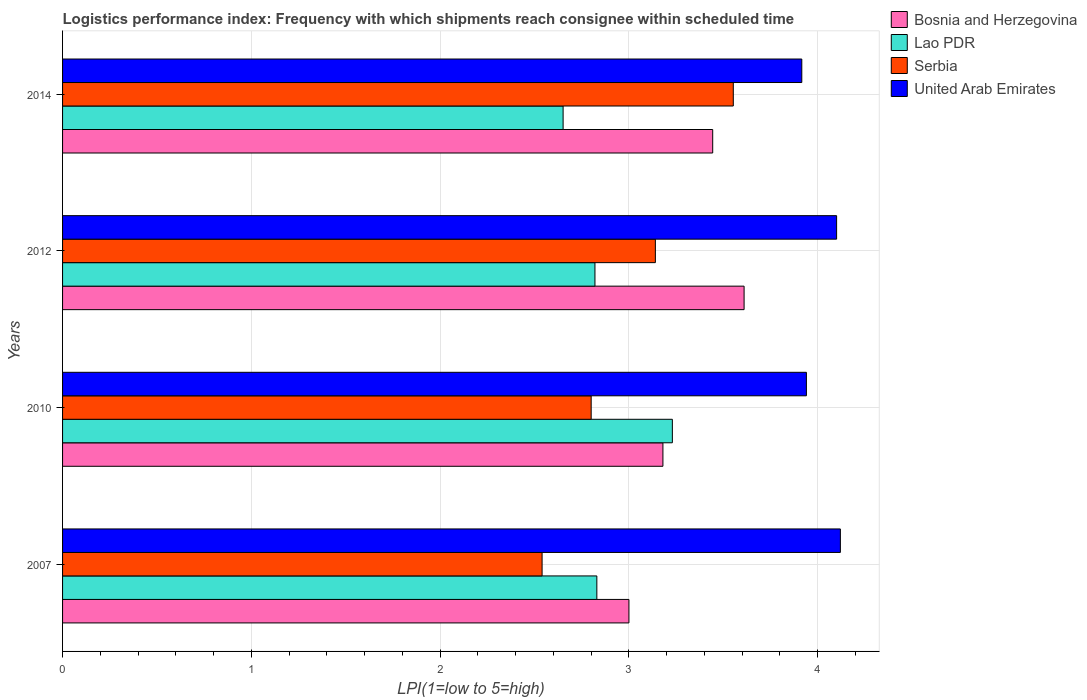How many different coloured bars are there?
Ensure brevity in your answer.  4. How many groups of bars are there?
Give a very brief answer. 4. Are the number of bars per tick equal to the number of legend labels?
Offer a terse response. Yes. How many bars are there on the 2nd tick from the top?
Give a very brief answer. 4. What is the label of the 2nd group of bars from the top?
Your answer should be very brief. 2012. What is the logistics performance index in Bosnia and Herzegovina in 2014?
Ensure brevity in your answer.  3.44. Across all years, what is the maximum logistics performance index in United Arab Emirates?
Keep it short and to the point. 4.12. Across all years, what is the minimum logistics performance index in Serbia?
Provide a short and direct response. 2.54. In which year was the logistics performance index in Bosnia and Herzegovina maximum?
Your answer should be very brief. 2012. In which year was the logistics performance index in Serbia minimum?
Offer a terse response. 2007. What is the total logistics performance index in United Arab Emirates in the graph?
Make the answer very short. 16.08. What is the difference between the logistics performance index in Bosnia and Herzegovina in 2012 and that in 2014?
Ensure brevity in your answer.  0.17. What is the difference between the logistics performance index in Serbia in 2007 and the logistics performance index in Bosnia and Herzegovina in 2012?
Give a very brief answer. -1.07. What is the average logistics performance index in Bosnia and Herzegovina per year?
Provide a short and direct response. 3.31. In the year 2014, what is the difference between the logistics performance index in Bosnia and Herzegovina and logistics performance index in Serbia?
Keep it short and to the point. -0.11. In how many years, is the logistics performance index in Serbia greater than 2.6 ?
Offer a very short reply. 3. What is the ratio of the logistics performance index in Bosnia and Herzegovina in 2010 to that in 2014?
Give a very brief answer. 0.92. Is the difference between the logistics performance index in Bosnia and Herzegovina in 2007 and 2014 greater than the difference between the logistics performance index in Serbia in 2007 and 2014?
Your answer should be very brief. Yes. What is the difference between the highest and the second highest logistics performance index in United Arab Emirates?
Your answer should be compact. 0.02. What is the difference between the highest and the lowest logistics performance index in Bosnia and Herzegovina?
Offer a very short reply. 0.61. What does the 1st bar from the top in 2007 represents?
Your answer should be very brief. United Arab Emirates. What does the 1st bar from the bottom in 2007 represents?
Offer a very short reply. Bosnia and Herzegovina. Is it the case that in every year, the sum of the logistics performance index in Bosnia and Herzegovina and logistics performance index in Serbia is greater than the logistics performance index in United Arab Emirates?
Your answer should be very brief. Yes. Are all the bars in the graph horizontal?
Your answer should be very brief. Yes. How many years are there in the graph?
Your answer should be compact. 4. What is the difference between two consecutive major ticks on the X-axis?
Keep it short and to the point. 1. Are the values on the major ticks of X-axis written in scientific E-notation?
Give a very brief answer. No. Does the graph contain grids?
Your response must be concise. Yes. Where does the legend appear in the graph?
Your response must be concise. Top right. How many legend labels are there?
Make the answer very short. 4. How are the legend labels stacked?
Keep it short and to the point. Vertical. What is the title of the graph?
Your answer should be compact. Logistics performance index: Frequency with which shipments reach consignee within scheduled time. Does "Middle East & North Africa (developing only)" appear as one of the legend labels in the graph?
Your answer should be compact. No. What is the label or title of the X-axis?
Give a very brief answer. LPI(1=low to 5=high). What is the LPI(1=low to 5=high) in Bosnia and Herzegovina in 2007?
Offer a very short reply. 3. What is the LPI(1=low to 5=high) in Lao PDR in 2007?
Provide a short and direct response. 2.83. What is the LPI(1=low to 5=high) in Serbia in 2007?
Make the answer very short. 2.54. What is the LPI(1=low to 5=high) in United Arab Emirates in 2007?
Offer a very short reply. 4.12. What is the LPI(1=low to 5=high) in Bosnia and Herzegovina in 2010?
Ensure brevity in your answer.  3.18. What is the LPI(1=low to 5=high) of Lao PDR in 2010?
Your answer should be very brief. 3.23. What is the LPI(1=low to 5=high) in Serbia in 2010?
Provide a succinct answer. 2.8. What is the LPI(1=low to 5=high) of United Arab Emirates in 2010?
Your answer should be compact. 3.94. What is the LPI(1=low to 5=high) in Bosnia and Herzegovina in 2012?
Provide a short and direct response. 3.61. What is the LPI(1=low to 5=high) in Lao PDR in 2012?
Offer a terse response. 2.82. What is the LPI(1=low to 5=high) in Serbia in 2012?
Provide a short and direct response. 3.14. What is the LPI(1=low to 5=high) of Bosnia and Herzegovina in 2014?
Make the answer very short. 3.44. What is the LPI(1=low to 5=high) of Lao PDR in 2014?
Keep it short and to the point. 2.65. What is the LPI(1=low to 5=high) of Serbia in 2014?
Offer a very short reply. 3.55. What is the LPI(1=low to 5=high) in United Arab Emirates in 2014?
Give a very brief answer. 3.92. Across all years, what is the maximum LPI(1=low to 5=high) in Bosnia and Herzegovina?
Provide a succinct answer. 3.61. Across all years, what is the maximum LPI(1=low to 5=high) of Lao PDR?
Your answer should be compact. 3.23. Across all years, what is the maximum LPI(1=low to 5=high) in Serbia?
Ensure brevity in your answer.  3.55. Across all years, what is the maximum LPI(1=low to 5=high) of United Arab Emirates?
Provide a short and direct response. 4.12. Across all years, what is the minimum LPI(1=low to 5=high) in Lao PDR?
Keep it short and to the point. 2.65. Across all years, what is the minimum LPI(1=low to 5=high) in Serbia?
Your answer should be very brief. 2.54. Across all years, what is the minimum LPI(1=low to 5=high) in United Arab Emirates?
Offer a terse response. 3.92. What is the total LPI(1=low to 5=high) of Bosnia and Herzegovina in the graph?
Offer a very short reply. 13.23. What is the total LPI(1=low to 5=high) of Lao PDR in the graph?
Keep it short and to the point. 11.53. What is the total LPI(1=low to 5=high) of Serbia in the graph?
Provide a short and direct response. 12.03. What is the total LPI(1=low to 5=high) of United Arab Emirates in the graph?
Give a very brief answer. 16.08. What is the difference between the LPI(1=low to 5=high) of Bosnia and Herzegovina in 2007 and that in 2010?
Your answer should be very brief. -0.18. What is the difference between the LPI(1=low to 5=high) of Lao PDR in 2007 and that in 2010?
Offer a very short reply. -0.4. What is the difference between the LPI(1=low to 5=high) in Serbia in 2007 and that in 2010?
Give a very brief answer. -0.26. What is the difference between the LPI(1=low to 5=high) in United Arab Emirates in 2007 and that in 2010?
Provide a short and direct response. 0.18. What is the difference between the LPI(1=low to 5=high) of Bosnia and Herzegovina in 2007 and that in 2012?
Your answer should be very brief. -0.61. What is the difference between the LPI(1=low to 5=high) of Serbia in 2007 and that in 2012?
Offer a terse response. -0.6. What is the difference between the LPI(1=low to 5=high) of United Arab Emirates in 2007 and that in 2012?
Ensure brevity in your answer.  0.02. What is the difference between the LPI(1=low to 5=high) of Bosnia and Herzegovina in 2007 and that in 2014?
Offer a terse response. -0.44. What is the difference between the LPI(1=low to 5=high) of Lao PDR in 2007 and that in 2014?
Offer a very short reply. 0.18. What is the difference between the LPI(1=low to 5=high) in Serbia in 2007 and that in 2014?
Offer a terse response. -1.01. What is the difference between the LPI(1=low to 5=high) of United Arab Emirates in 2007 and that in 2014?
Provide a succinct answer. 0.2. What is the difference between the LPI(1=low to 5=high) of Bosnia and Herzegovina in 2010 and that in 2012?
Your answer should be very brief. -0.43. What is the difference between the LPI(1=low to 5=high) of Lao PDR in 2010 and that in 2012?
Offer a very short reply. 0.41. What is the difference between the LPI(1=low to 5=high) of Serbia in 2010 and that in 2012?
Make the answer very short. -0.34. What is the difference between the LPI(1=low to 5=high) of United Arab Emirates in 2010 and that in 2012?
Provide a short and direct response. -0.16. What is the difference between the LPI(1=low to 5=high) in Bosnia and Herzegovina in 2010 and that in 2014?
Offer a very short reply. -0.26. What is the difference between the LPI(1=low to 5=high) of Lao PDR in 2010 and that in 2014?
Keep it short and to the point. 0.58. What is the difference between the LPI(1=low to 5=high) in Serbia in 2010 and that in 2014?
Offer a terse response. -0.75. What is the difference between the LPI(1=low to 5=high) of United Arab Emirates in 2010 and that in 2014?
Provide a short and direct response. 0.02. What is the difference between the LPI(1=low to 5=high) of Bosnia and Herzegovina in 2012 and that in 2014?
Offer a very short reply. 0.17. What is the difference between the LPI(1=low to 5=high) in Lao PDR in 2012 and that in 2014?
Provide a succinct answer. 0.17. What is the difference between the LPI(1=low to 5=high) in Serbia in 2012 and that in 2014?
Give a very brief answer. -0.41. What is the difference between the LPI(1=low to 5=high) in United Arab Emirates in 2012 and that in 2014?
Keep it short and to the point. 0.18. What is the difference between the LPI(1=low to 5=high) in Bosnia and Herzegovina in 2007 and the LPI(1=low to 5=high) in Lao PDR in 2010?
Your response must be concise. -0.23. What is the difference between the LPI(1=low to 5=high) in Bosnia and Herzegovina in 2007 and the LPI(1=low to 5=high) in Serbia in 2010?
Provide a short and direct response. 0.2. What is the difference between the LPI(1=low to 5=high) of Bosnia and Herzegovina in 2007 and the LPI(1=low to 5=high) of United Arab Emirates in 2010?
Ensure brevity in your answer.  -0.94. What is the difference between the LPI(1=low to 5=high) in Lao PDR in 2007 and the LPI(1=low to 5=high) in United Arab Emirates in 2010?
Ensure brevity in your answer.  -1.11. What is the difference between the LPI(1=low to 5=high) of Bosnia and Herzegovina in 2007 and the LPI(1=low to 5=high) of Lao PDR in 2012?
Provide a succinct answer. 0.18. What is the difference between the LPI(1=low to 5=high) in Bosnia and Herzegovina in 2007 and the LPI(1=low to 5=high) in Serbia in 2012?
Provide a succinct answer. -0.14. What is the difference between the LPI(1=low to 5=high) of Bosnia and Herzegovina in 2007 and the LPI(1=low to 5=high) of United Arab Emirates in 2012?
Keep it short and to the point. -1.1. What is the difference between the LPI(1=low to 5=high) of Lao PDR in 2007 and the LPI(1=low to 5=high) of Serbia in 2012?
Make the answer very short. -0.31. What is the difference between the LPI(1=low to 5=high) of Lao PDR in 2007 and the LPI(1=low to 5=high) of United Arab Emirates in 2012?
Provide a succinct answer. -1.27. What is the difference between the LPI(1=low to 5=high) of Serbia in 2007 and the LPI(1=low to 5=high) of United Arab Emirates in 2012?
Ensure brevity in your answer.  -1.56. What is the difference between the LPI(1=low to 5=high) in Bosnia and Herzegovina in 2007 and the LPI(1=low to 5=high) in Lao PDR in 2014?
Ensure brevity in your answer.  0.35. What is the difference between the LPI(1=low to 5=high) in Bosnia and Herzegovina in 2007 and the LPI(1=low to 5=high) in Serbia in 2014?
Your response must be concise. -0.55. What is the difference between the LPI(1=low to 5=high) in Bosnia and Herzegovina in 2007 and the LPI(1=low to 5=high) in United Arab Emirates in 2014?
Offer a terse response. -0.92. What is the difference between the LPI(1=low to 5=high) in Lao PDR in 2007 and the LPI(1=low to 5=high) in Serbia in 2014?
Your response must be concise. -0.72. What is the difference between the LPI(1=low to 5=high) of Lao PDR in 2007 and the LPI(1=low to 5=high) of United Arab Emirates in 2014?
Offer a very short reply. -1.09. What is the difference between the LPI(1=low to 5=high) in Serbia in 2007 and the LPI(1=low to 5=high) in United Arab Emirates in 2014?
Keep it short and to the point. -1.38. What is the difference between the LPI(1=low to 5=high) in Bosnia and Herzegovina in 2010 and the LPI(1=low to 5=high) in Lao PDR in 2012?
Give a very brief answer. 0.36. What is the difference between the LPI(1=low to 5=high) of Bosnia and Herzegovina in 2010 and the LPI(1=low to 5=high) of United Arab Emirates in 2012?
Provide a succinct answer. -0.92. What is the difference between the LPI(1=low to 5=high) of Lao PDR in 2010 and the LPI(1=low to 5=high) of Serbia in 2012?
Provide a short and direct response. 0.09. What is the difference between the LPI(1=low to 5=high) in Lao PDR in 2010 and the LPI(1=low to 5=high) in United Arab Emirates in 2012?
Ensure brevity in your answer.  -0.87. What is the difference between the LPI(1=low to 5=high) in Bosnia and Herzegovina in 2010 and the LPI(1=low to 5=high) in Lao PDR in 2014?
Your answer should be compact. 0.53. What is the difference between the LPI(1=low to 5=high) in Bosnia and Herzegovina in 2010 and the LPI(1=low to 5=high) in Serbia in 2014?
Offer a terse response. -0.37. What is the difference between the LPI(1=low to 5=high) of Bosnia and Herzegovina in 2010 and the LPI(1=low to 5=high) of United Arab Emirates in 2014?
Offer a terse response. -0.74. What is the difference between the LPI(1=low to 5=high) in Lao PDR in 2010 and the LPI(1=low to 5=high) in Serbia in 2014?
Provide a succinct answer. -0.32. What is the difference between the LPI(1=low to 5=high) of Lao PDR in 2010 and the LPI(1=low to 5=high) of United Arab Emirates in 2014?
Offer a terse response. -0.69. What is the difference between the LPI(1=low to 5=high) in Serbia in 2010 and the LPI(1=low to 5=high) in United Arab Emirates in 2014?
Offer a terse response. -1.12. What is the difference between the LPI(1=low to 5=high) of Bosnia and Herzegovina in 2012 and the LPI(1=low to 5=high) of Lao PDR in 2014?
Provide a succinct answer. 0.96. What is the difference between the LPI(1=low to 5=high) of Bosnia and Herzegovina in 2012 and the LPI(1=low to 5=high) of Serbia in 2014?
Offer a very short reply. 0.06. What is the difference between the LPI(1=low to 5=high) of Bosnia and Herzegovina in 2012 and the LPI(1=low to 5=high) of United Arab Emirates in 2014?
Make the answer very short. -0.31. What is the difference between the LPI(1=low to 5=high) in Lao PDR in 2012 and the LPI(1=low to 5=high) in Serbia in 2014?
Ensure brevity in your answer.  -0.73. What is the difference between the LPI(1=low to 5=high) of Lao PDR in 2012 and the LPI(1=low to 5=high) of United Arab Emirates in 2014?
Give a very brief answer. -1.1. What is the difference between the LPI(1=low to 5=high) of Serbia in 2012 and the LPI(1=low to 5=high) of United Arab Emirates in 2014?
Ensure brevity in your answer.  -0.78. What is the average LPI(1=low to 5=high) of Bosnia and Herzegovina per year?
Give a very brief answer. 3.31. What is the average LPI(1=low to 5=high) of Lao PDR per year?
Offer a very short reply. 2.88. What is the average LPI(1=low to 5=high) in Serbia per year?
Offer a very short reply. 3.01. What is the average LPI(1=low to 5=high) of United Arab Emirates per year?
Your answer should be compact. 4.02. In the year 2007, what is the difference between the LPI(1=low to 5=high) in Bosnia and Herzegovina and LPI(1=low to 5=high) in Lao PDR?
Ensure brevity in your answer.  0.17. In the year 2007, what is the difference between the LPI(1=low to 5=high) in Bosnia and Herzegovina and LPI(1=low to 5=high) in Serbia?
Give a very brief answer. 0.46. In the year 2007, what is the difference between the LPI(1=low to 5=high) of Bosnia and Herzegovina and LPI(1=low to 5=high) of United Arab Emirates?
Provide a succinct answer. -1.12. In the year 2007, what is the difference between the LPI(1=low to 5=high) of Lao PDR and LPI(1=low to 5=high) of Serbia?
Offer a terse response. 0.29. In the year 2007, what is the difference between the LPI(1=low to 5=high) of Lao PDR and LPI(1=low to 5=high) of United Arab Emirates?
Offer a very short reply. -1.29. In the year 2007, what is the difference between the LPI(1=low to 5=high) of Serbia and LPI(1=low to 5=high) of United Arab Emirates?
Offer a very short reply. -1.58. In the year 2010, what is the difference between the LPI(1=low to 5=high) in Bosnia and Herzegovina and LPI(1=low to 5=high) in Serbia?
Offer a terse response. 0.38. In the year 2010, what is the difference between the LPI(1=low to 5=high) in Bosnia and Herzegovina and LPI(1=low to 5=high) in United Arab Emirates?
Your response must be concise. -0.76. In the year 2010, what is the difference between the LPI(1=low to 5=high) of Lao PDR and LPI(1=low to 5=high) of Serbia?
Provide a succinct answer. 0.43. In the year 2010, what is the difference between the LPI(1=low to 5=high) of Lao PDR and LPI(1=low to 5=high) of United Arab Emirates?
Ensure brevity in your answer.  -0.71. In the year 2010, what is the difference between the LPI(1=low to 5=high) in Serbia and LPI(1=low to 5=high) in United Arab Emirates?
Make the answer very short. -1.14. In the year 2012, what is the difference between the LPI(1=low to 5=high) of Bosnia and Herzegovina and LPI(1=low to 5=high) of Lao PDR?
Offer a very short reply. 0.79. In the year 2012, what is the difference between the LPI(1=low to 5=high) in Bosnia and Herzegovina and LPI(1=low to 5=high) in Serbia?
Your response must be concise. 0.47. In the year 2012, what is the difference between the LPI(1=low to 5=high) of Bosnia and Herzegovina and LPI(1=low to 5=high) of United Arab Emirates?
Make the answer very short. -0.49. In the year 2012, what is the difference between the LPI(1=low to 5=high) in Lao PDR and LPI(1=low to 5=high) in Serbia?
Offer a very short reply. -0.32. In the year 2012, what is the difference between the LPI(1=low to 5=high) in Lao PDR and LPI(1=low to 5=high) in United Arab Emirates?
Provide a succinct answer. -1.28. In the year 2012, what is the difference between the LPI(1=low to 5=high) of Serbia and LPI(1=low to 5=high) of United Arab Emirates?
Your answer should be compact. -0.96. In the year 2014, what is the difference between the LPI(1=low to 5=high) of Bosnia and Herzegovina and LPI(1=low to 5=high) of Lao PDR?
Give a very brief answer. 0.79. In the year 2014, what is the difference between the LPI(1=low to 5=high) of Bosnia and Herzegovina and LPI(1=low to 5=high) of Serbia?
Your response must be concise. -0.11. In the year 2014, what is the difference between the LPI(1=low to 5=high) in Bosnia and Herzegovina and LPI(1=low to 5=high) in United Arab Emirates?
Offer a terse response. -0.47. In the year 2014, what is the difference between the LPI(1=low to 5=high) of Lao PDR and LPI(1=low to 5=high) of Serbia?
Ensure brevity in your answer.  -0.9. In the year 2014, what is the difference between the LPI(1=low to 5=high) of Lao PDR and LPI(1=low to 5=high) of United Arab Emirates?
Offer a very short reply. -1.26. In the year 2014, what is the difference between the LPI(1=low to 5=high) of Serbia and LPI(1=low to 5=high) of United Arab Emirates?
Offer a terse response. -0.36. What is the ratio of the LPI(1=low to 5=high) in Bosnia and Herzegovina in 2007 to that in 2010?
Your response must be concise. 0.94. What is the ratio of the LPI(1=low to 5=high) of Lao PDR in 2007 to that in 2010?
Give a very brief answer. 0.88. What is the ratio of the LPI(1=low to 5=high) in Serbia in 2007 to that in 2010?
Make the answer very short. 0.91. What is the ratio of the LPI(1=low to 5=high) in United Arab Emirates in 2007 to that in 2010?
Provide a short and direct response. 1.05. What is the ratio of the LPI(1=low to 5=high) in Bosnia and Herzegovina in 2007 to that in 2012?
Keep it short and to the point. 0.83. What is the ratio of the LPI(1=low to 5=high) in Lao PDR in 2007 to that in 2012?
Your response must be concise. 1. What is the ratio of the LPI(1=low to 5=high) in Serbia in 2007 to that in 2012?
Ensure brevity in your answer.  0.81. What is the ratio of the LPI(1=low to 5=high) of Bosnia and Herzegovina in 2007 to that in 2014?
Keep it short and to the point. 0.87. What is the ratio of the LPI(1=low to 5=high) of Lao PDR in 2007 to that in 2014?
Your response must be concise. 1.07. What is the ratio of the LPI(1=low to 5=high) of Serbia in 2007 to that in 2014?
Make the answer very short. 0.71. What is the ratio of the LPI(1=low to 5=high) of United Arab Emirates in 2007 to that in 2014?
Offer a terse response. 1.05. What is the ratio of the LPI(1=low to 5=high) of Bosnia and Herzegovina in 2010 to that in 2012?
Provide a succinct answer. 0.88. What is the ratio of the LPI(1=low to 5=high) in Lao PDR in 2010 to that in 2012?
Provide a succinct answer. 1.15. What is the ratio of the LPI(1=low to 5=high) of Serbia in 2010 to that in 2012?
Keep it short and to the point. 0.89. What is the ratio of the LPI(1=low to 5=high) of Bosnia and Herzegovina in 2010 to that in 2014?
Offer a very short reply. 0.92. What is the ratio of the LPI(1=low to 5=high) of Lao PDR in 2010 to that in 2014?
Give a very brief answer. 1.22. What is the ratio of the LPI(1=low to 5=high) of Serbia in 2010 to that in 2014?
Make the answer very short. 0.79. What is the ratio of the LPI(1=low to 5=high) of United Arab Emirates in 2010 to that in 2014?
Offer a terse response. 1.01. What is the ratio of the LPI(1=low to 5=high) in Bosnia and Herzegovina in 2012 to that in 2014?
Provide a short and direct response. 1.05. What is the ratio of the LPI(1=low to 5=high) of Lao PDR in 2012 to that in 2014?
Your answer should be very brief. 1.06. What is the ratio of the LPI(1=low to 5=high) of Serbia in 2012 to that in 2014?
Offer a terse response. 0.88. What is the ratio of the LPI(1=low to 5=high) of United Arab Emirates in 2012 to that in 2014?
Offer a very short reply. 1.05. What is the difference between the highest and the second highest LPI(1=low to 5=high) in Bosnia and Herzegovina?
Your response must be concise. 0.17. What is the difference between the highest and the second highest LPI(1=low to 5=high) of Serbia?
Provide a short and direct response. 0.41. What is the difference between the highest and the lowest LPI(1=low to 5=high) of Bosnia and Herzegovina?
Your answer should be very brief. 0.61. What is the difference between the highest and the lowest LPI(1=low to 5=high) of Lao PDR?
Your answer should be compact. 0.58. What is the difference between the highest and the lowest LPI(1=low to 5=high) of Serbia?
Give a very brief answer. 1.01. What is the difference between the highest and the lowest LPI(1=low to 5=high) in United Arab Emirates?
Ensure brevity in your answer.  0.2. 